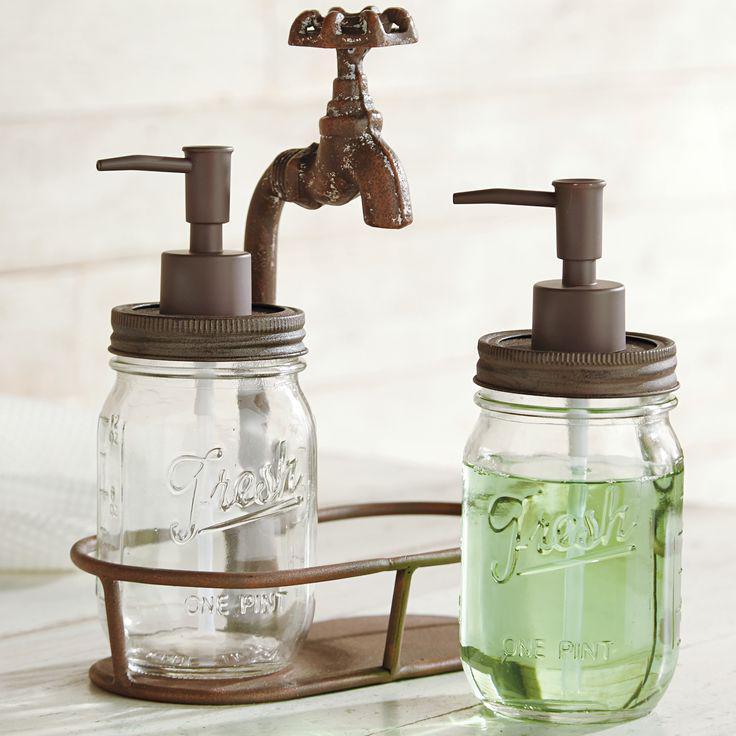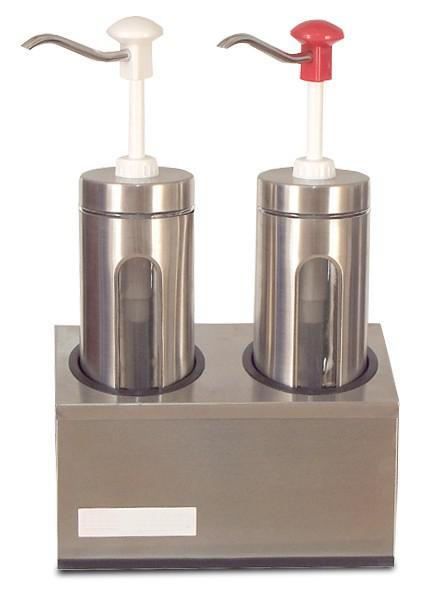The first image is the image on the left, the second image is the image on the right. For the images displayed, is the sentence "Each image shows a pair of pump dispensers, and each pair of dispensers is shown with a caddy holder." factually correct? Answer yes or no. Yes. 